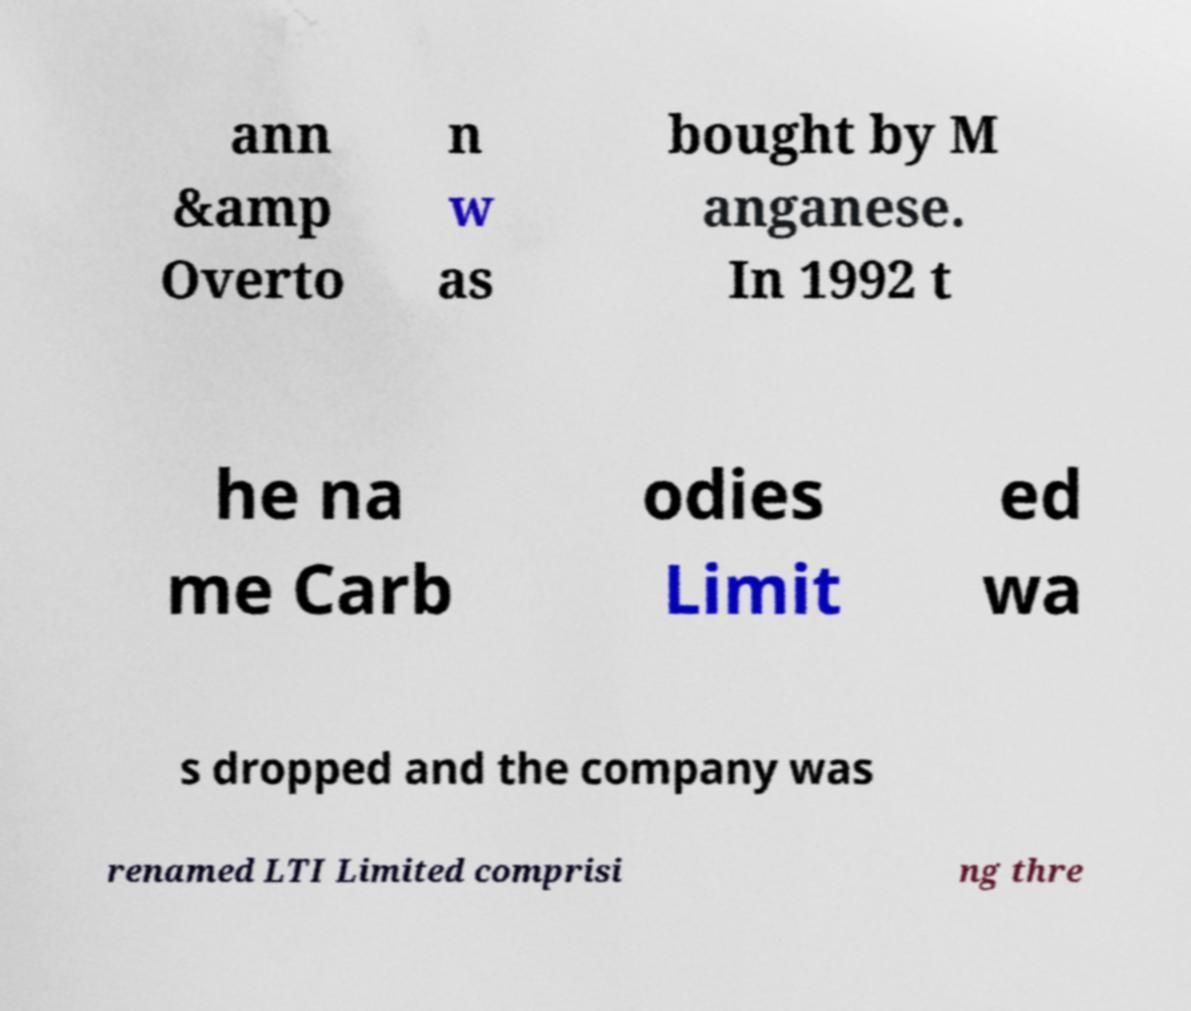For documentation purposes, I need the text within this image transcribed. Could you provide that? ann &amp Overto n w as bought by M anganese. In 1992 t he na me Carb odies Limit ed wa s dropped and the company was renamed LTI Limited comprisi ng thre 